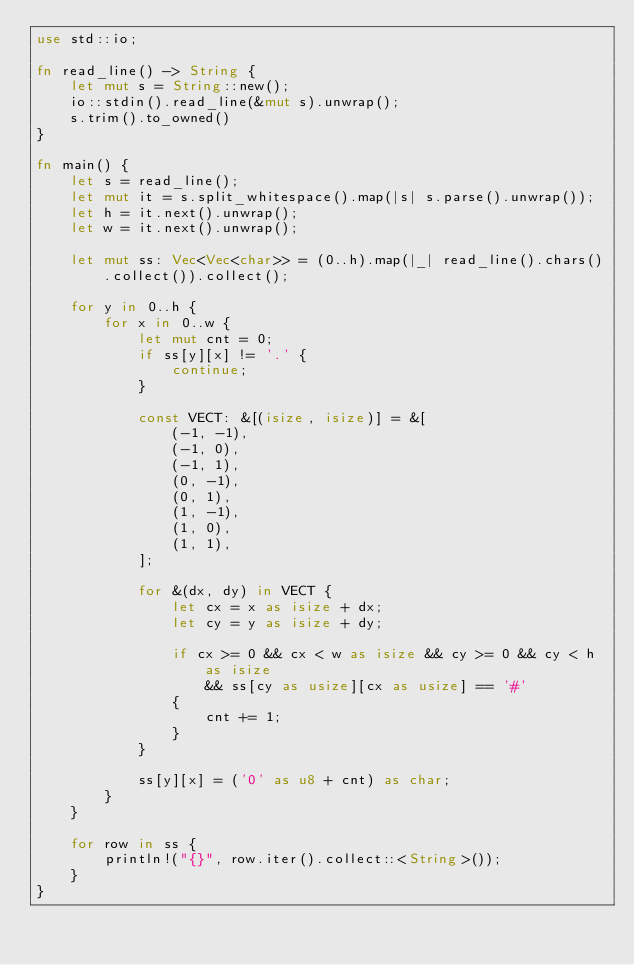Convert code to text. <code><loc_0><loc_0><loc_500><loc_500><_Rust_>use std::io;

fn read_line() -> String {
    let mut s = String::new();
    io::stdin().read_line(&mut s).unwrap();
    s.trim().to_owned()
}

fn main() {
    let s = read_line();
    let mut it = s.split_whitespace().map(|s| s.parse().unwrap());
    let h = it.next().unwrap();
    let w = it.next().unwrap();

    let mut ss: Vec<Vec<char>> = (0..h).map(|_| read_line().chars().collect()).collect();

    for y in 0..h {
        for x in 0..w {
            let mut cnt = 0;
            if ss[y][x] != '.' {
                continue;
            }

            const VECT: &[(isize, isize)] = &[
                (-1, -1),
                (-1, 0),
                (-1, 1),
                (0, -1),
                (0, 1),
                (1, -1),
                (1, 0),
                (1, 1),
            ];

            for &(dx, dy) in VECT {
                let cx = x as isize + dx;
                let cy = y as isize + dy;

                if cx >= 0 && cx < w as isize && cy >= 0 && cy < h as isize
                    && ss[cy as usize][cx as usize] == '#'
                {
                    cnt += 1;
                }
            }

            ss[y][x] = ('0' as u8 + cnt) as char;
        }
    }

    for row in ss {
        println!("{}", row.iter().collect::<String>());
    }
}
</code> 